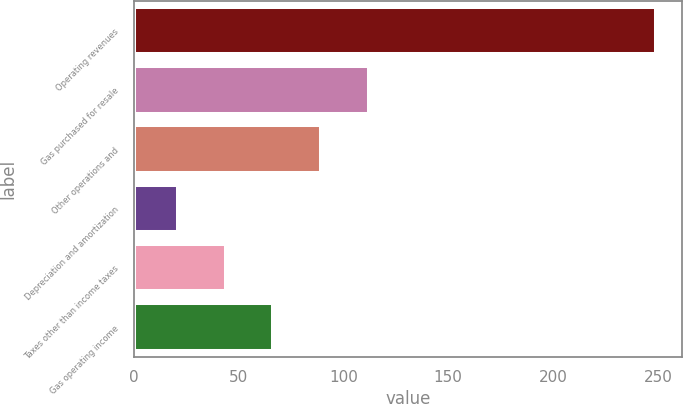<chart> <loc_0><loc_0><loc_500><loc_500><bar_chart><fcel>Operating revenues<fcel>Gas purchased for resale<fcel>Other operations and<fcel>Depreciation and amortization<fcel>Taxes other than income taxes<fcel>Gas operating income<nl><fcel>249<fcel>112.2<fcel>89.4<fcel>21<fcel>43.8<fcel>66.6<nl></chart> 